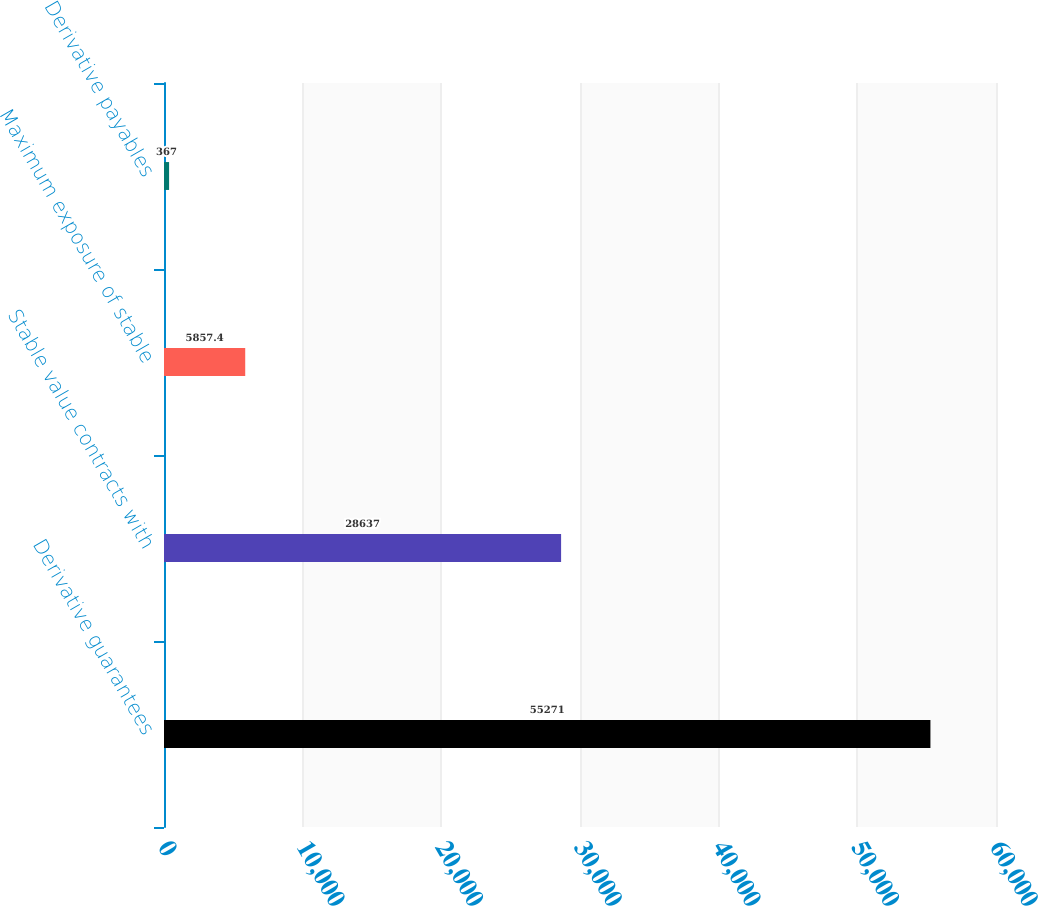Convert chart to OTSL. <chart><loc_0><loc_0><loc_500><loc_500><bar_chart><fcel>Derivative guarantees<fcel>Stable value contracts with<fcel>Maximum exposure of stable<fcel>Derivative payables<nl><fcel>55271<fcel>28637<fcel>5857.4<fcel>367<nl></chart> 